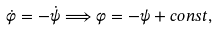<formula> <loc_0><loc_0><loc_500><loc_500>\dot { \varphi } = - \dot { \psi } \Longrightarrow \varphi = - \psi + c o n s t ,</formula> 